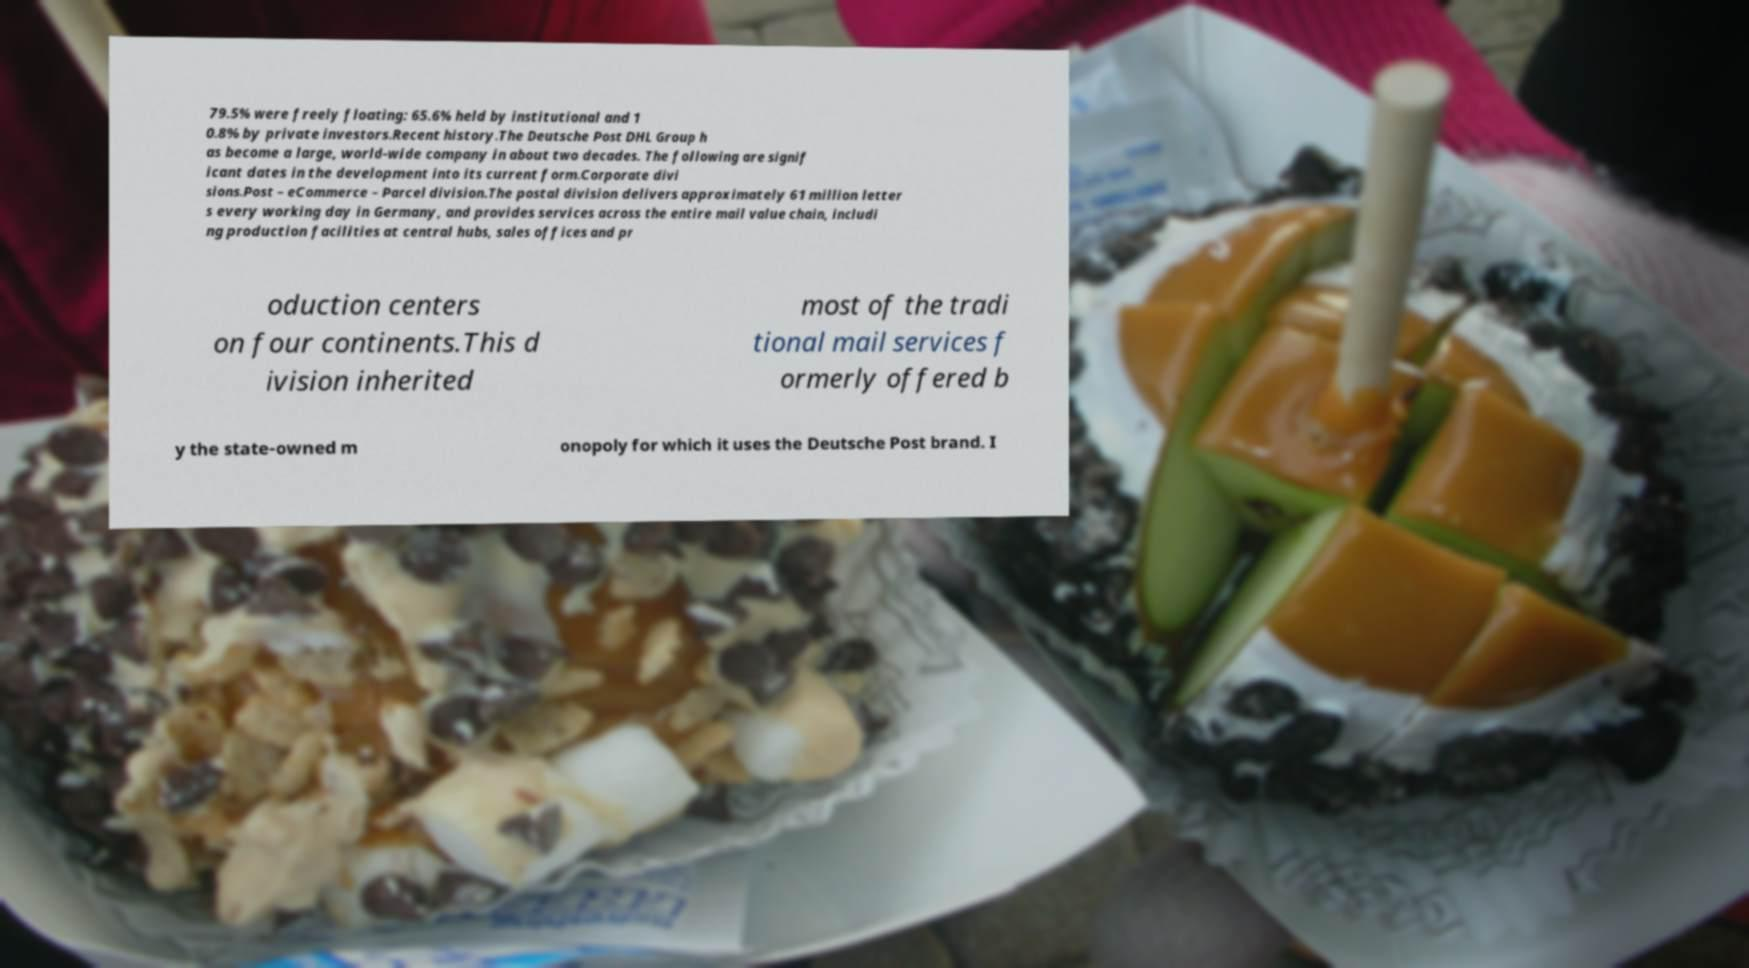Can you read and provide the text displayed in the image?This photo seems to have some interesting text. Can you extract and type it out for me? 79.5% were freely floating: 65.6% held by institutional and 1 0.8% by private investors.Recent history.The Deutsche Post DHL Group h as become a large, world-wide company in about two decades. The following are signif icant dates in the development into its current form.Corporate divi sions.Post – eCommerce – Parcel division.The postal division delivers approximately 61 million letter s every working day in Germany, and provides services across the entire mail value chain, includi ng production facilities at central hubs, sales offices and pr oduction centers on four continents.This d ivision inherited most of the tradi tional mail services f ormerly offered b y the state-owned m onopoly for which it uses the Deutsche Post brand. I 